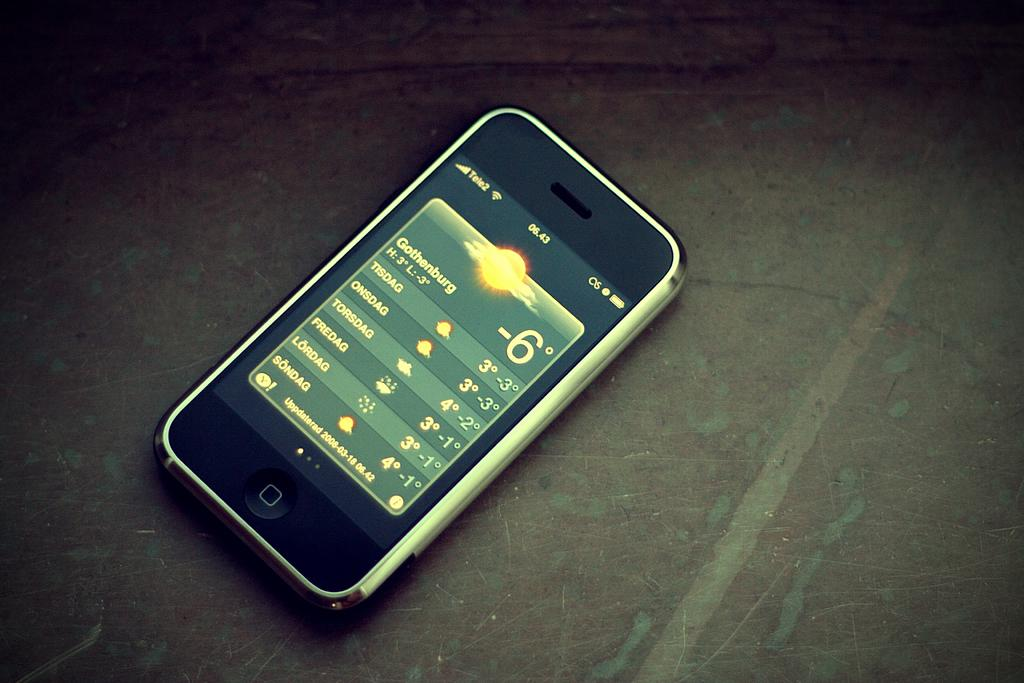<image>
Relay a brief, clear account of the picture shown. A cell phone displays that the temperature in Gothenburg is -6 degrees. 